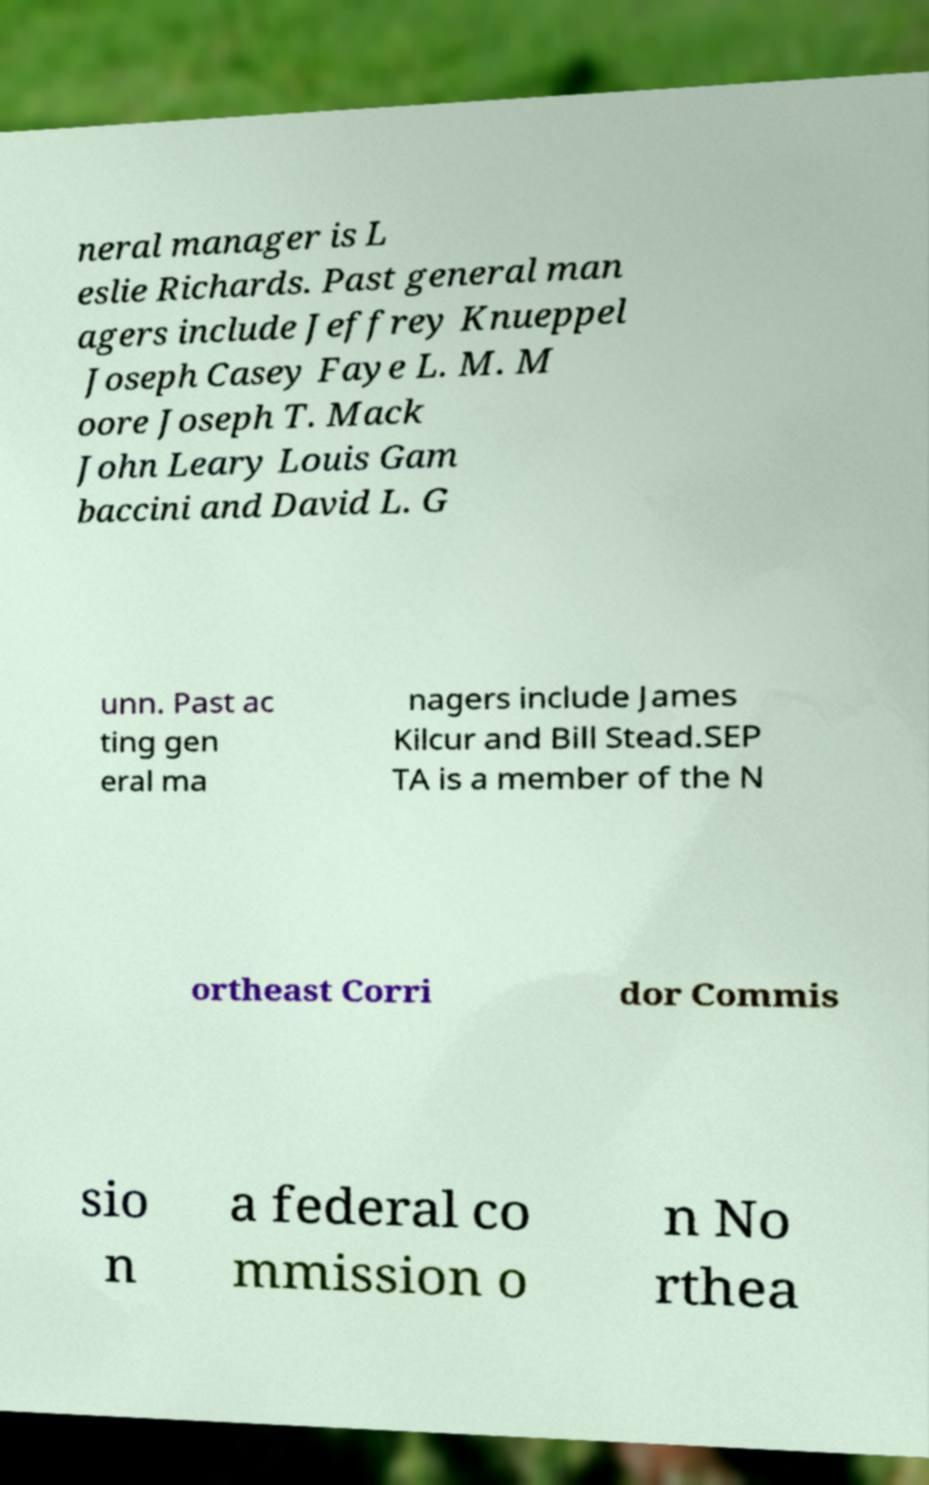There's text embedded in this image that I need extracted. Can you transcribe it verbatim? neral manager is L eslie Richards. Past general man agers include Jeffrey Knueppel Joseph Casey Faye L. M. M oore Joseph T. Mack John Leary Louis Gam baccini and David L. G unn. Past ac ting gen eral ma nagers include James Kilcur and Bill Stead.SEP TA is a member of the N ortheast Corri dor Commis sio n a federal co mmission o n No rthea 